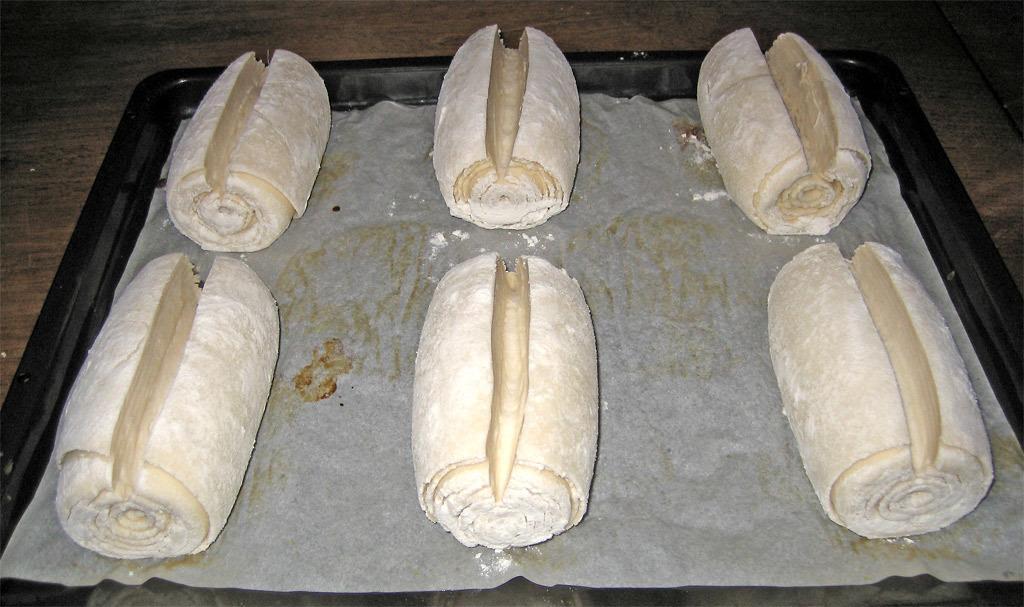How would you summarize this image in a sentence or two? In this picture I can see there is some food placed on the tray and it is placed on the wooden table. 